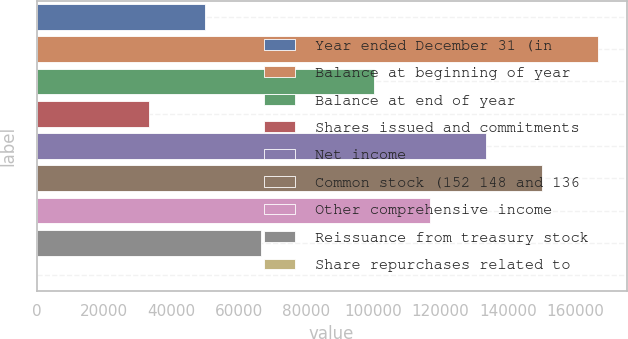Convert chart. <chart><loc_0><loc_0><loc_500><loc_500><bar_chart><fcel>Year ended December 31 (in<fcel>Balance at beginning of year<fcel>Balance at end of year<fcel>Shares issued and commitments<fcel>Net income<fcel>Common stock (152 148 and 136<fcel>Other comprehensive income<fcel>Reissuance from treasury stock<fcel>Share repurchases related to<nl><fcel>50079.9<fcel>166884<fcel>100139<fcel>33393.6<fcel>133511<fcel>150198<fcel>116825<fcel>66766.2<fcel>21<nl></chart> 